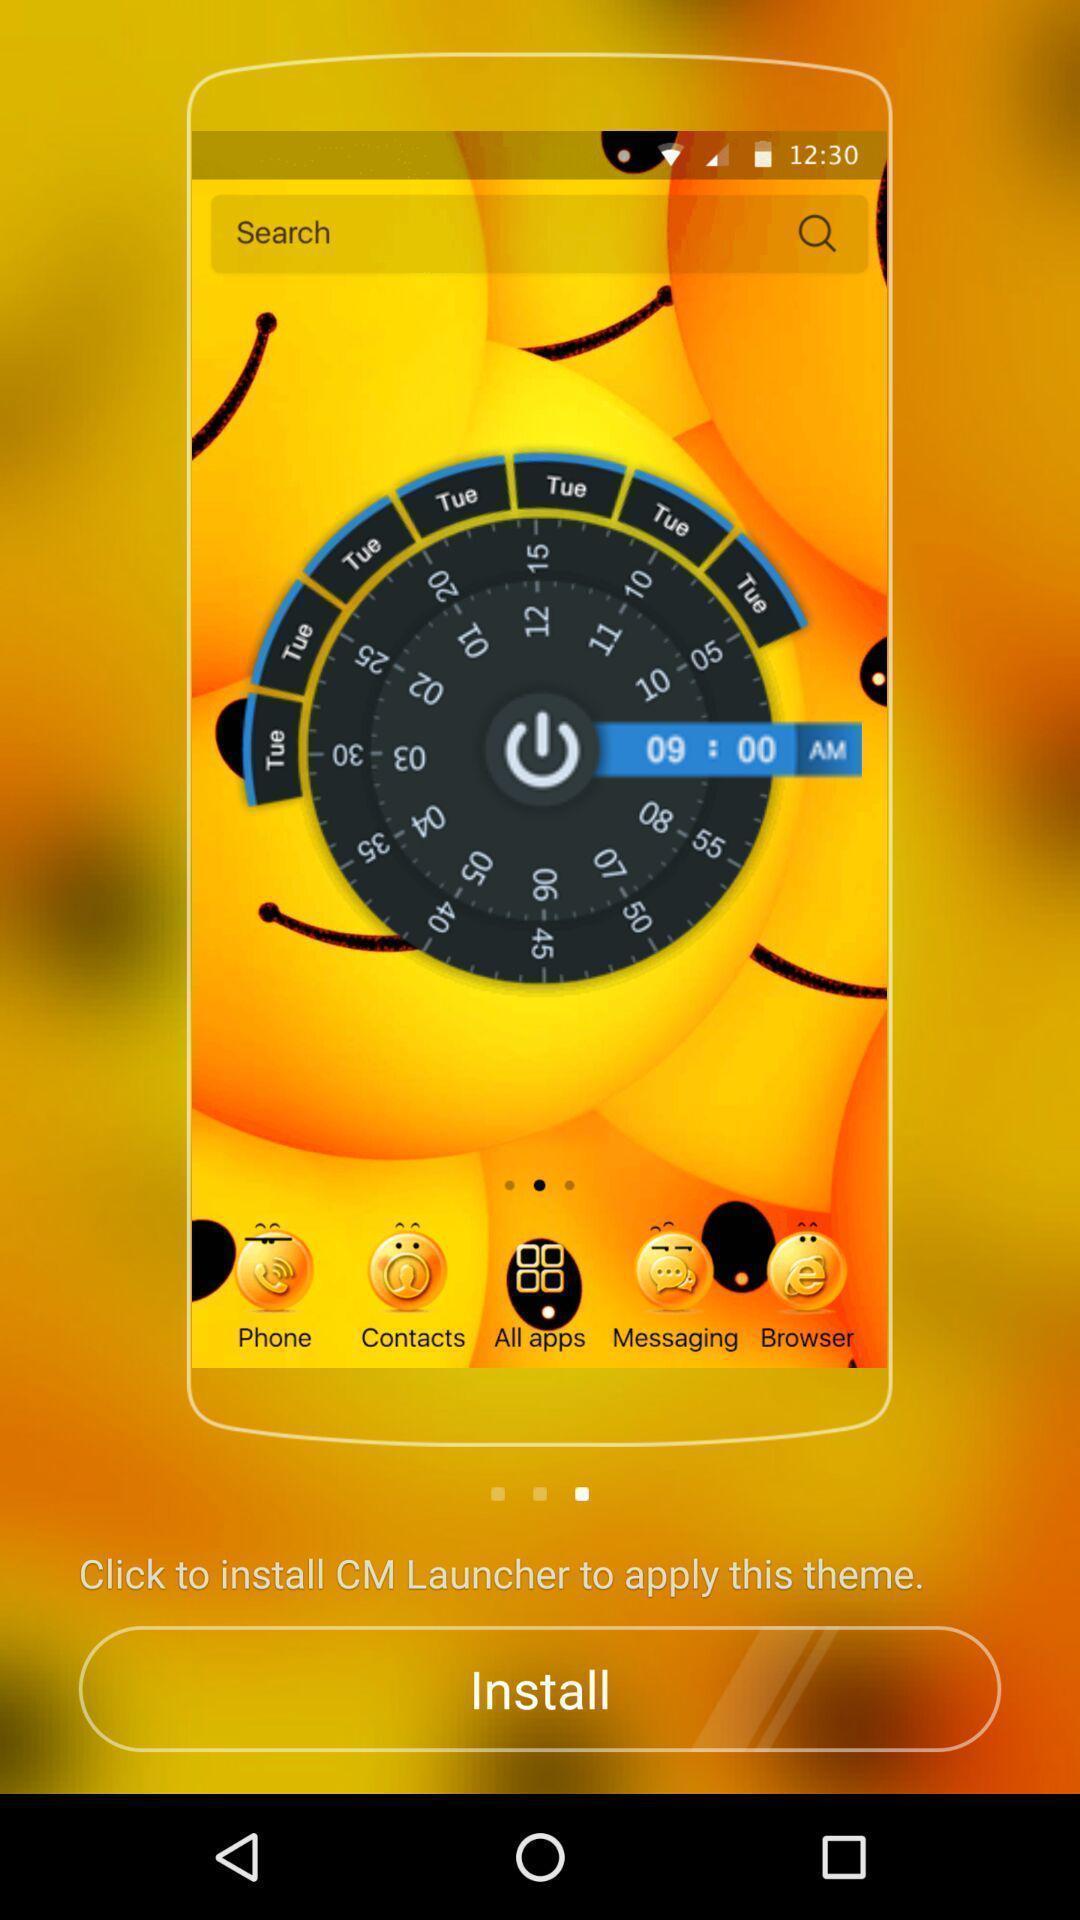What is the overall content of this screenshot? Screen displaying to install application to apply the theme. 